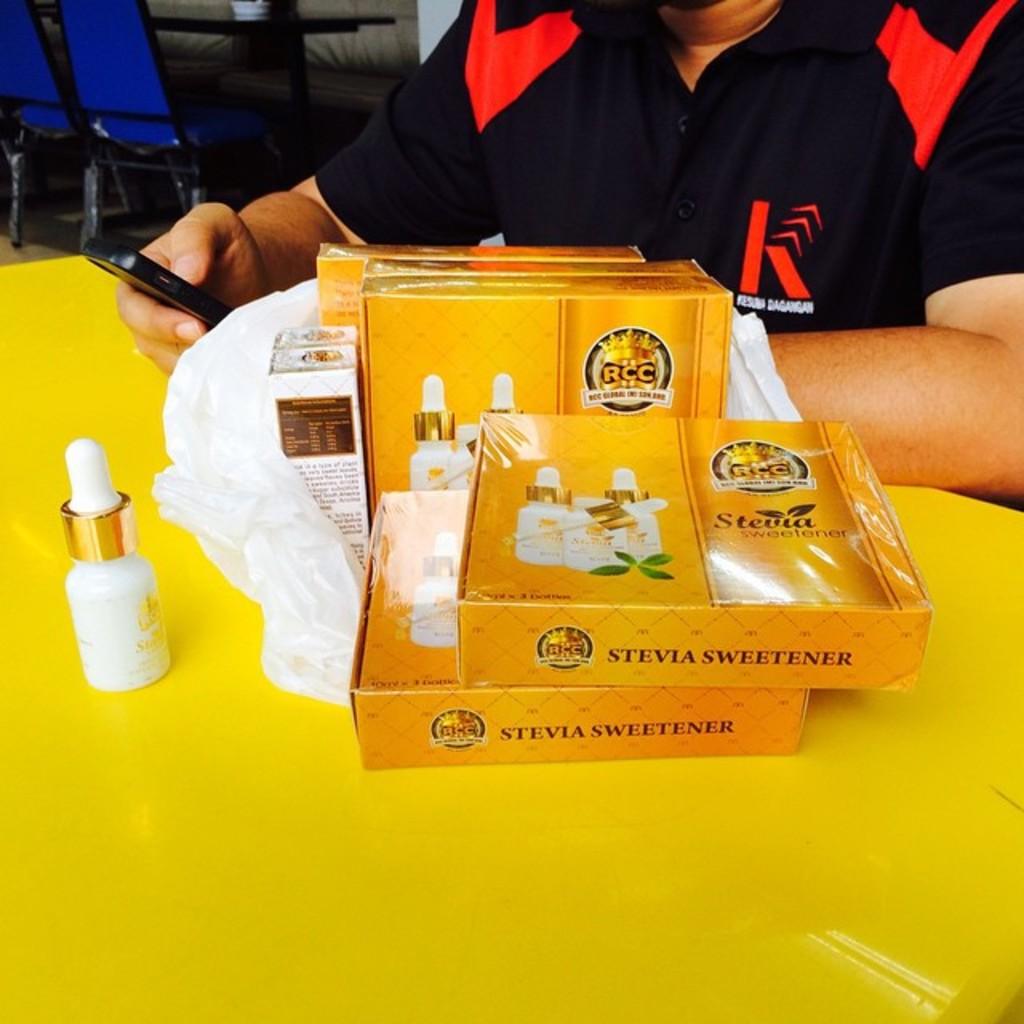Who makes this product? three letters?
Make the answer very short. Rcc. 